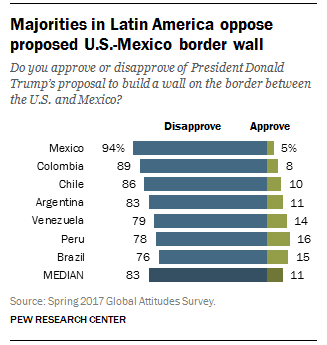Mention a couple of crucial points in this snapshot. According to the survey, in multiple countries, more than 12% of the respondents support the proposed US-Mexico border wall, with the exact number unspecified. According to a recent survey, approximately 5% of the Mexican population approves of the US-Mexico border wall. 